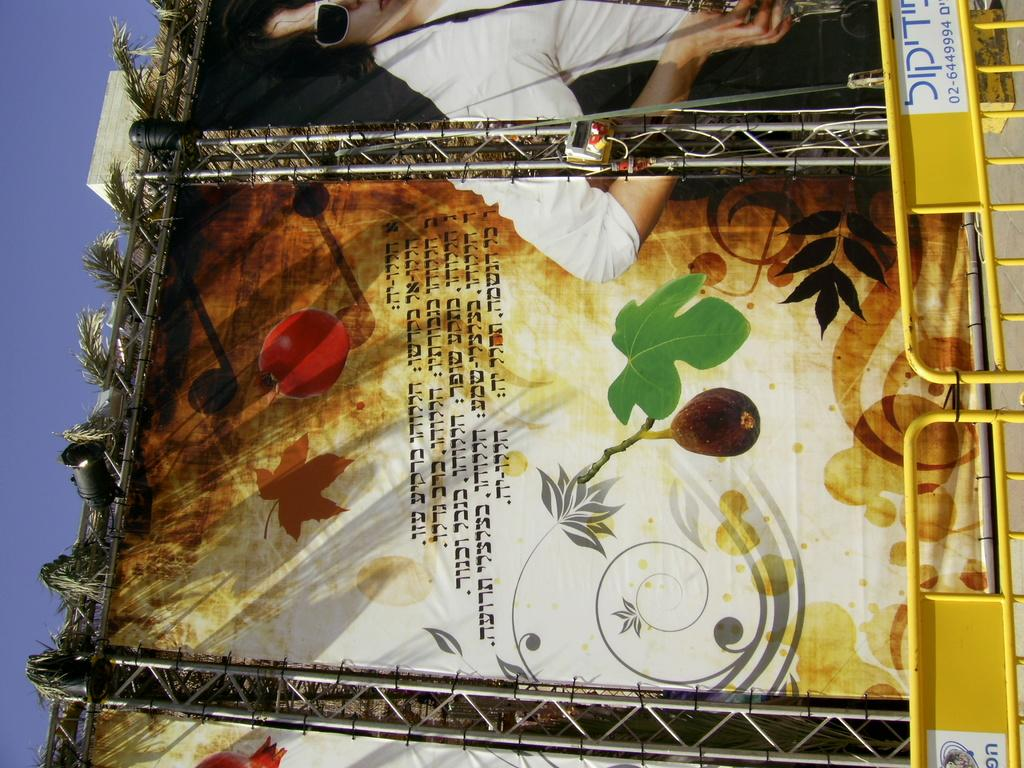What type of structure is located at the front of the image? There are metal grills at the front of the image. What can be seen at the back side of the image? There is a banner at the back side of the image. What is visible in the background of the image? The sky is visible in the background of the image. Can you tell me how many jellyfish are swimming in the sky in the image? There are no jellyfish present in the image; it features metal grills, a banner, and the sky. What degree of education does the person holding the banner have? There is no person holding the banner in the image, so it is not possible to determine their level of education. 